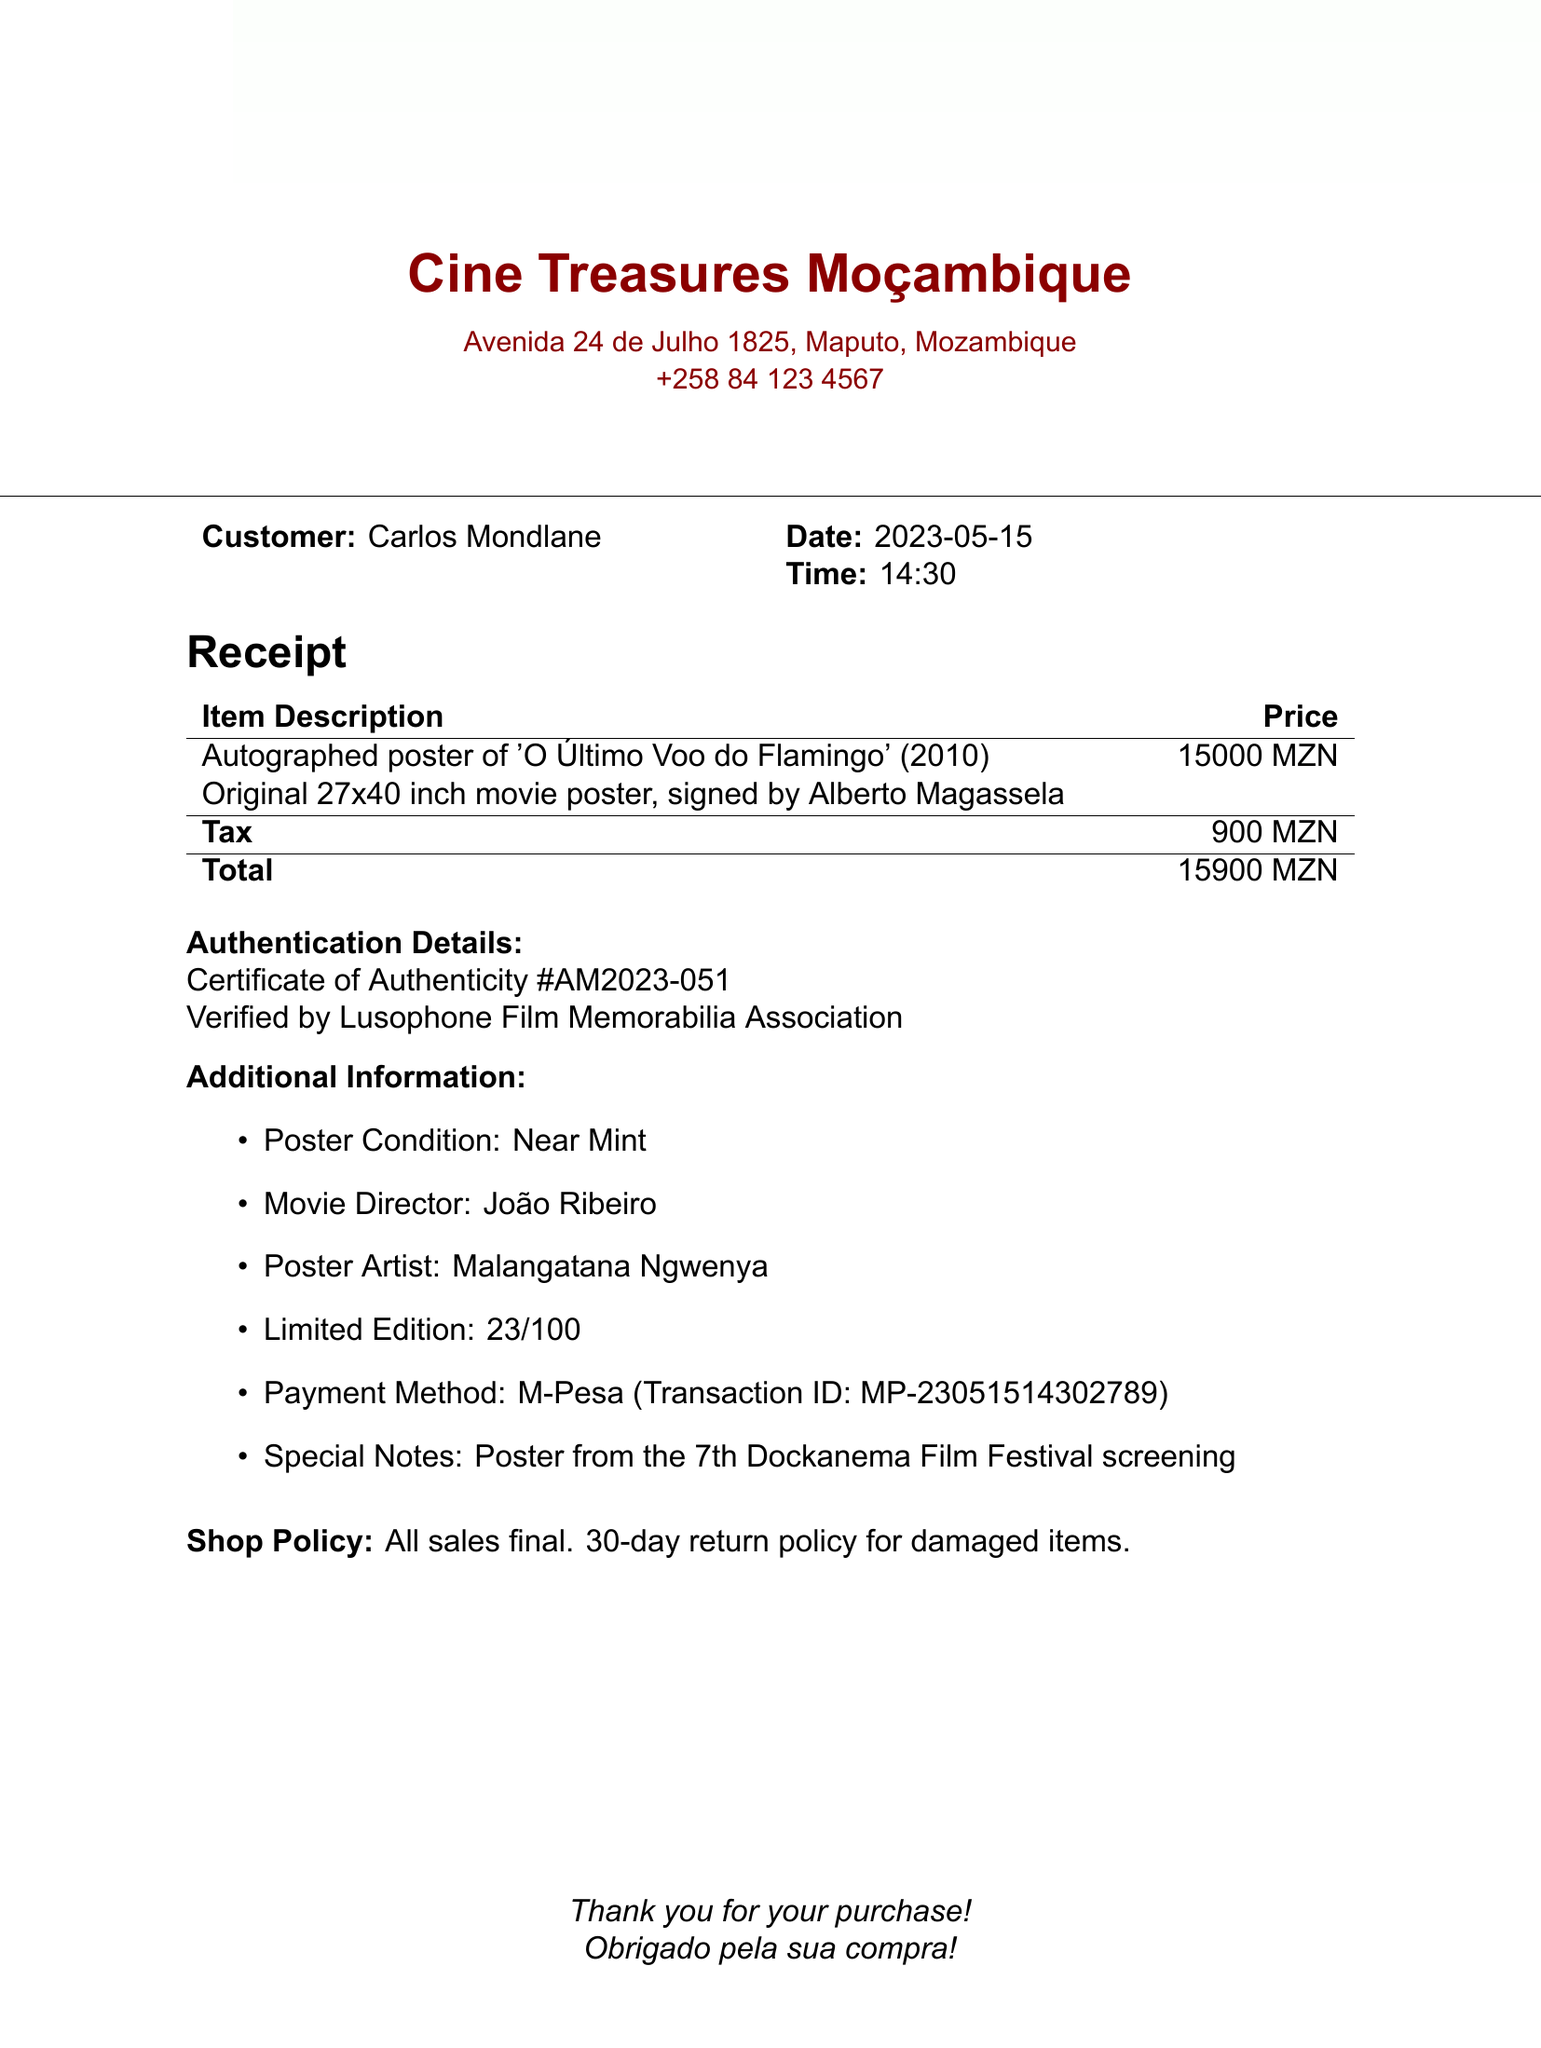What is the name of the shop? The shop is identified with its name at the top of the document.
Answer: Cine Treasures Moçambique What is the item purchased? The item is described prominently in the receipt as the main purchase.
Answer: Autographed poster of 'O Último Voo do Flamingo' (2010) Who is the customer? The customer's name is stated clearly near the top of the receipt.
Answer: Carlos Mondlane What was the date of purchase? The date is mentioned alongside the customer's details on the receipt.
Answer: 2023-05-15 What is the total amount paid? The total payment is calculated at the end of the receipt, after taxes.
Answer: 15900 MZN What is the payment method used? The payment method is outlined in the additional information section of the receipt.
Answer: M-Pesa What is the certificate number for authenticity? The certificate of authenticity is explicitly mentioned in the authentication details.
Answer: AM2023-051 Who signed the poster? The signature on the poster is attributed to the individual recognized in the item description.
Answer: Alberto Magassela What edition number is the poster? The limited edition number is stated in the additional information section.
Answer: 23/100 